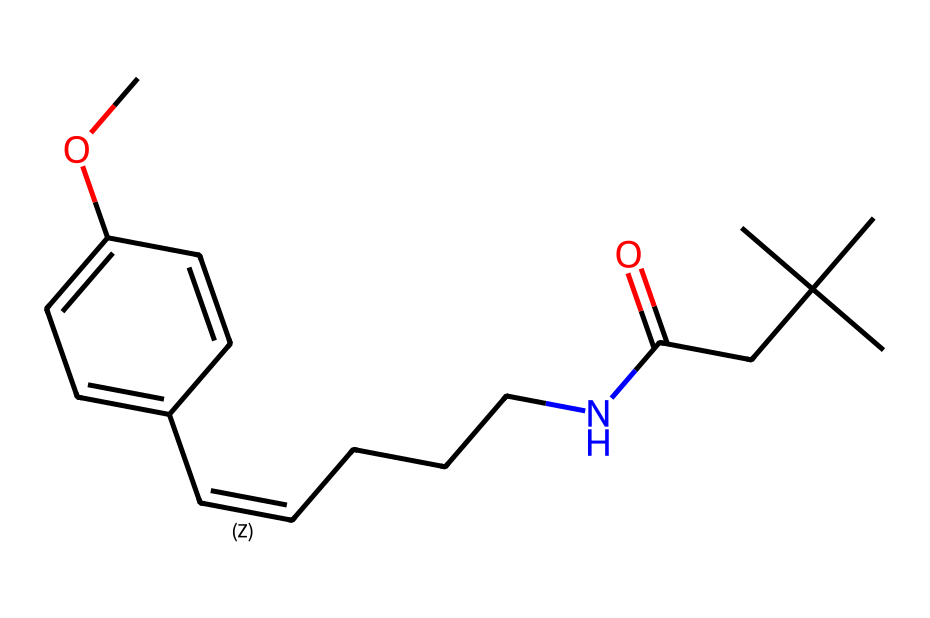What is the molecular formula of capsaicin? By examining the structure and accounting for all carbon, hydrogen, nitrogen, and oxygen atoms, the molecular formula can be calculated as C18H27NO3.
Answer: C18H27NO3 How many rings are present in the structure of capsaicin? The structure shows a benzene ring, which is a six-membered carbon ring commonly found in phenolic compounds, and does not contain any other rings.
Answer: 1 What functional group is present in capsaicin that contributes to its aromatic nature? The presence of the hydroxyl group (-OH) bonded to the benzene ring characterizes it as a phenolic compound, contributing to its aromatic properties.
Answer: hydroxyl What is the total number of carbon atoms in capsaicin? By counting the carbon atoms present in the structure, there are 18 carbon atoms in total.
Answer: 18 How many hydrogen atoms are attached to the nitrogen in capsaicin? In the structure, there is one nitrogen atom that is attached to one hydrogen atom, as evident from the partial structure NH.
Answer: 1 Which part of the capsaicin structure is responsible for its spiciness? The long alkyl chain and specific orientation of functional groups around the aromatic ring provide the unique spiciness, primarily through the structure's interaction with capsaicin receptors.
Answer: alkyl chain What type of chemical bond primarily links the functional groups in capsaicin? The functional groups in capsaicin are primarily linked by single (sigma) bonds, which are the most common in organic compounds like this one.
Answer: single bond 